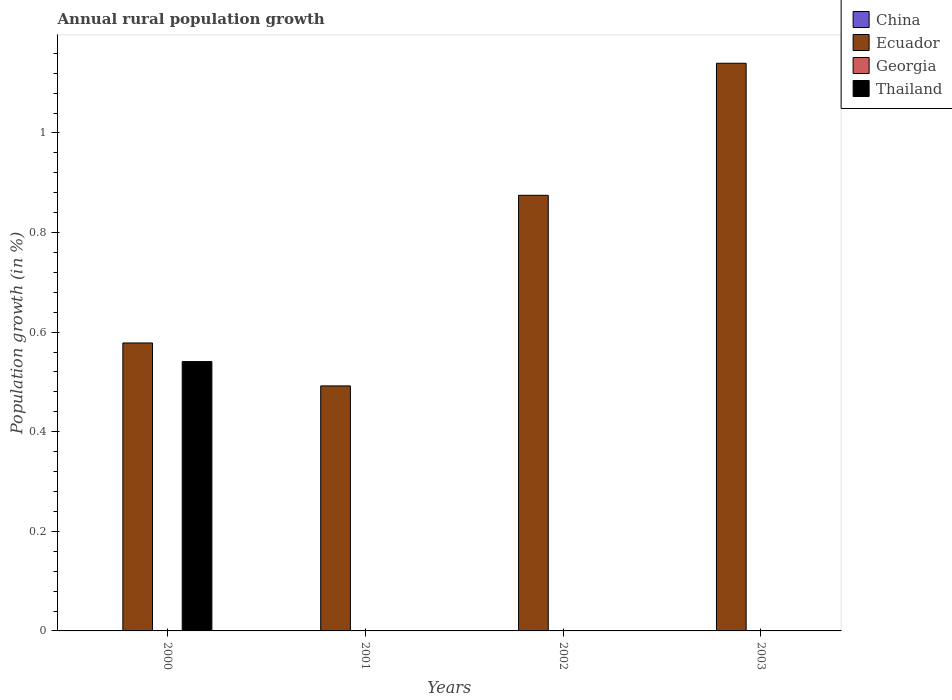How many different coloured bars are there?
Offer a very short reply. 2. Are the number of bars per tick equal to the number of legend labels?
Provide a succinct answer. No. In how many cases, is the number of bars for a given year not equal to the number of legend labels?
Provide a succinct answer. 4. Across all years, what is the maximum percentage of rural population growth in Ecuador?
Offer a very short reply. 1.14. Across all years, what is the minimum percentage of rural population growth in Thailand?
Give a very brief answer. 0. In which year was the percentage of rural population growth in Thailand maximum?
Your answer should be very brief. 2000. What is the total percentage of rural population growth in Thailand in the graph?
Ensure brevity in your answer.  0.54. What is the difference between the percentage of rural population growth in Ecuador in 2001 and that in 2002?
Your answer should be compact. -0.38. What is the difference between the percentage of rural population growth in China in 2000 and the percentage of rural population growth in Georgia in 2001?
Ensure brevity in your answer.  0. In the year 2000, what is the difference between the percentage of rural population growth in Thailand and percentage of rural population growth in Ecuador?
Provide a short and direct response. -0.04. In how many years, is the percentage of rural population growth in Thailand greater than 1.12 %?
Provide a short and direct response. 0. What is the ratio of the percentage of rural population growth in Ecuador in 2001 to that in 2003?
Make the answer very short. 0.43. Is the percentage of rural population growth in Ecuador in 2000 less than that in 2003?
Your response must be concise. Yes. What is the difference between the highest and the second highest percentage of rural population growth in Ecuador?
Your answer should be compact. 0.27. What is the difference between the highest and the lowest percentage of rural population growth in Ecuador?
Your answer should be compact. 0.65. Are all the bars in the graph horizontal?
Make the answer very short. No. How many years are there in the graph?
Your response must be concise. 4. What is the difference between two consecutive major ticks on the Y-axis?
Provide a succinct answer. 0.2. Does the graph contain any zero values?
Offer a terse response. Yes. Does the graph contain grids?
Your answer should be compact. No. Where does the legend appear in the graph?
Offer a very short reply. Top right. How are the legend labels stacked?
Your response must be concise. Vertical. What is the title of the graph?
Give a very brief answer. Annual rural population growth. Does "South Africa" appear as one of the legend labels in the graph?
Provide a succinct answer. No. What is the label or title of the Y-axis?
Your response must be concise. Population growth (in %). What is the Population growth (in %) in Ecuador in 2000?
Make the answer very short. 0.58. What is the Population growth (in %) in Thailand in 2000?
Ensure brevity in your answer.  0.54. What is the Population growth (in %) in China in 2001?
Keep it short and to the point. 0. What is the Population growth (in %) of Ecuador in 2001?
Provide a short and direct response. 0.49. What is the Population growth (in %) of Thailand in 2001?
Your answer should be very brief. 0. What is the Population growth (in %) in China in 2002?
Offer a terse response. 0. What is the Population growth (in %) of Ecuador in 2002?
Offer a terse response. 0.87. What is the Population growth (in %) in Thailand in 2002?
Offer a terse response. 0. What is the Population growth (in %) in China in 2003?
Make the answer very short. 0. What is the Population growth (in %) in Ecuador in 2003?
Make the answer very short. 1.14. What is the Population growth (in %) in Georgia in 2003?
Ensure brevity in your answer.  0. What is the Population growth (in %) of Thailand in 2003?
Keep it short and to the point. 0. Across all years, what is the maximum Population growth (in %) in Ecuador?
Give a very brief answer. 1.14. Across all years, what is the maximum Population growth (in %) of Thailand?
Offer a very short reply. 0.54. Across all years, what is the minimum Population growth (in %) in Ecuador?
Offer a very short reply. 0.49. What is the total Population growth (in %) of Ecuador in the graph?
Make the answer very short. 3.08. What is the total Population growth (in %) in Thailand in the graph?
Make the answer very short. 0.54. What is the difference between the Population growth (in %) in Ecuador in 2000 and that in 2001?
Your response must be concise. 0.09. What is the difference between the Population growth (in %) in Ecuador in 2000 and that in 2002?
Your answer should be very brief. -0.3. What is the difference between the Population growth (in %) in Ecuador in 2000 and that in 2003?
Provide a succinct answer. -0.56. What is the difference between the Population growth (in %) in Ecuador in 2001 and that in 2002?
Keep it short and to the point. -0.38. What is the difference between the Population growth (in %) in Ecuador in 2001 and that in 2003?
Provide a short and direct response. -0.65. What is the difference between the Population growth (in %) of Ecuador in 2002 and that in 2003?
Provide a short and direct response. -0.27. What is the average Population growth (in %) in Ecuador per year?
Your answer should be very brief. 0.77. What is the average Population growth (in %) of Georgia per year?
Offer a very short reply. 0. What is the average Population growth (in %) of Thailand per year?
Offer a very short reply. 0.14. In the year 2000, what is the difference between the Population growth (in %) of Ecuador and Population growth (in %) of Thailand?
Offer a very short reply. 0.04. What is the ratio of the Population growth (in %) in Ecuador in 2000 to that in 2001?
Your answer should be compact. 1.18. What is the ratio of the Population growth (in %) in Ecuador in 2000 to that in 2002?
Your answer should be compact. 0.66. What is the ratio of the Population growth (in %) of Ecuador in 2000 to that in 2003?
Your answer should be very brief. 0.51. What is the ratio of the Population growth (in %) in Ecuador in 2001 to that in 2002?
Your answer should be compact. 0.56. What is the ratio of the Population growth (in %) in Ecuador in 2001 to that in 2003?
Make the answer very short. 0.43. What is the ratio of the Population growth (in %) of Ecuador in 2002 to that in 2003?
Offer a very short reply. 0.77. What is the difference between the highest and the second highest Population growth (in %) in Ecuador?
Your response must be concise. 0.27. What is the difference between the highest and the lowest Population growth (in %) of Ecuador?
Provide a succinct answer. 0.65. What is the difference between the highest and the lowest Population growth (in %) of Thailand?
Give a very brief answer. 0.54. 